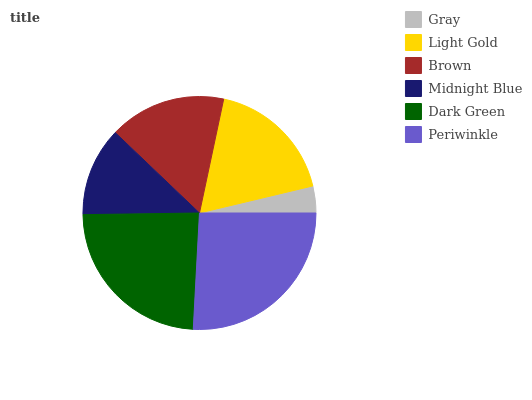Is Gray the minimum?
Answer yes or no. Yes. Is Periwinkle the maximum?
Answer yes or no. Yes. Is Light Gold the minimum?
Answer yes or no. No. Is Light Gold the maximum?
Answer yes or no. No. Is Light Gold greater than Gray?
Answer yes or no. Yes. Is Gray less than Light Gold?
Answer yes or no. Yes. Is Gray greater than Light Gold?
Answer yes or no. No. Is Light Gold less than Gray?
Answer yes or no. No. Is Light Gold the high median?
Answer yes or no. Yes. Is Brown the low median?
Answer yes or no. Yes. Is Periwinkle the high median?
Answer yes or no. No. Is Midnight Blue the low median?
Answer yes or no. No. 